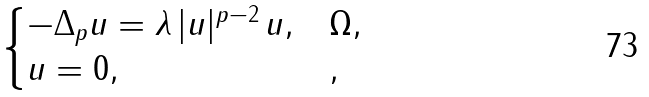<formula> <loc_0><loc_0><loc_500><loc_500>\begin{cases} - \Delta _ { p } u = \lambda \, | u | ^ { p - 2 } \, u , & \Omega , \\ u = 0 , & , \end{cases}</formula> 